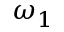<formula> <loc_0><loc_0><loc_500><loc_500>\omega _ { 1 }</formula> 